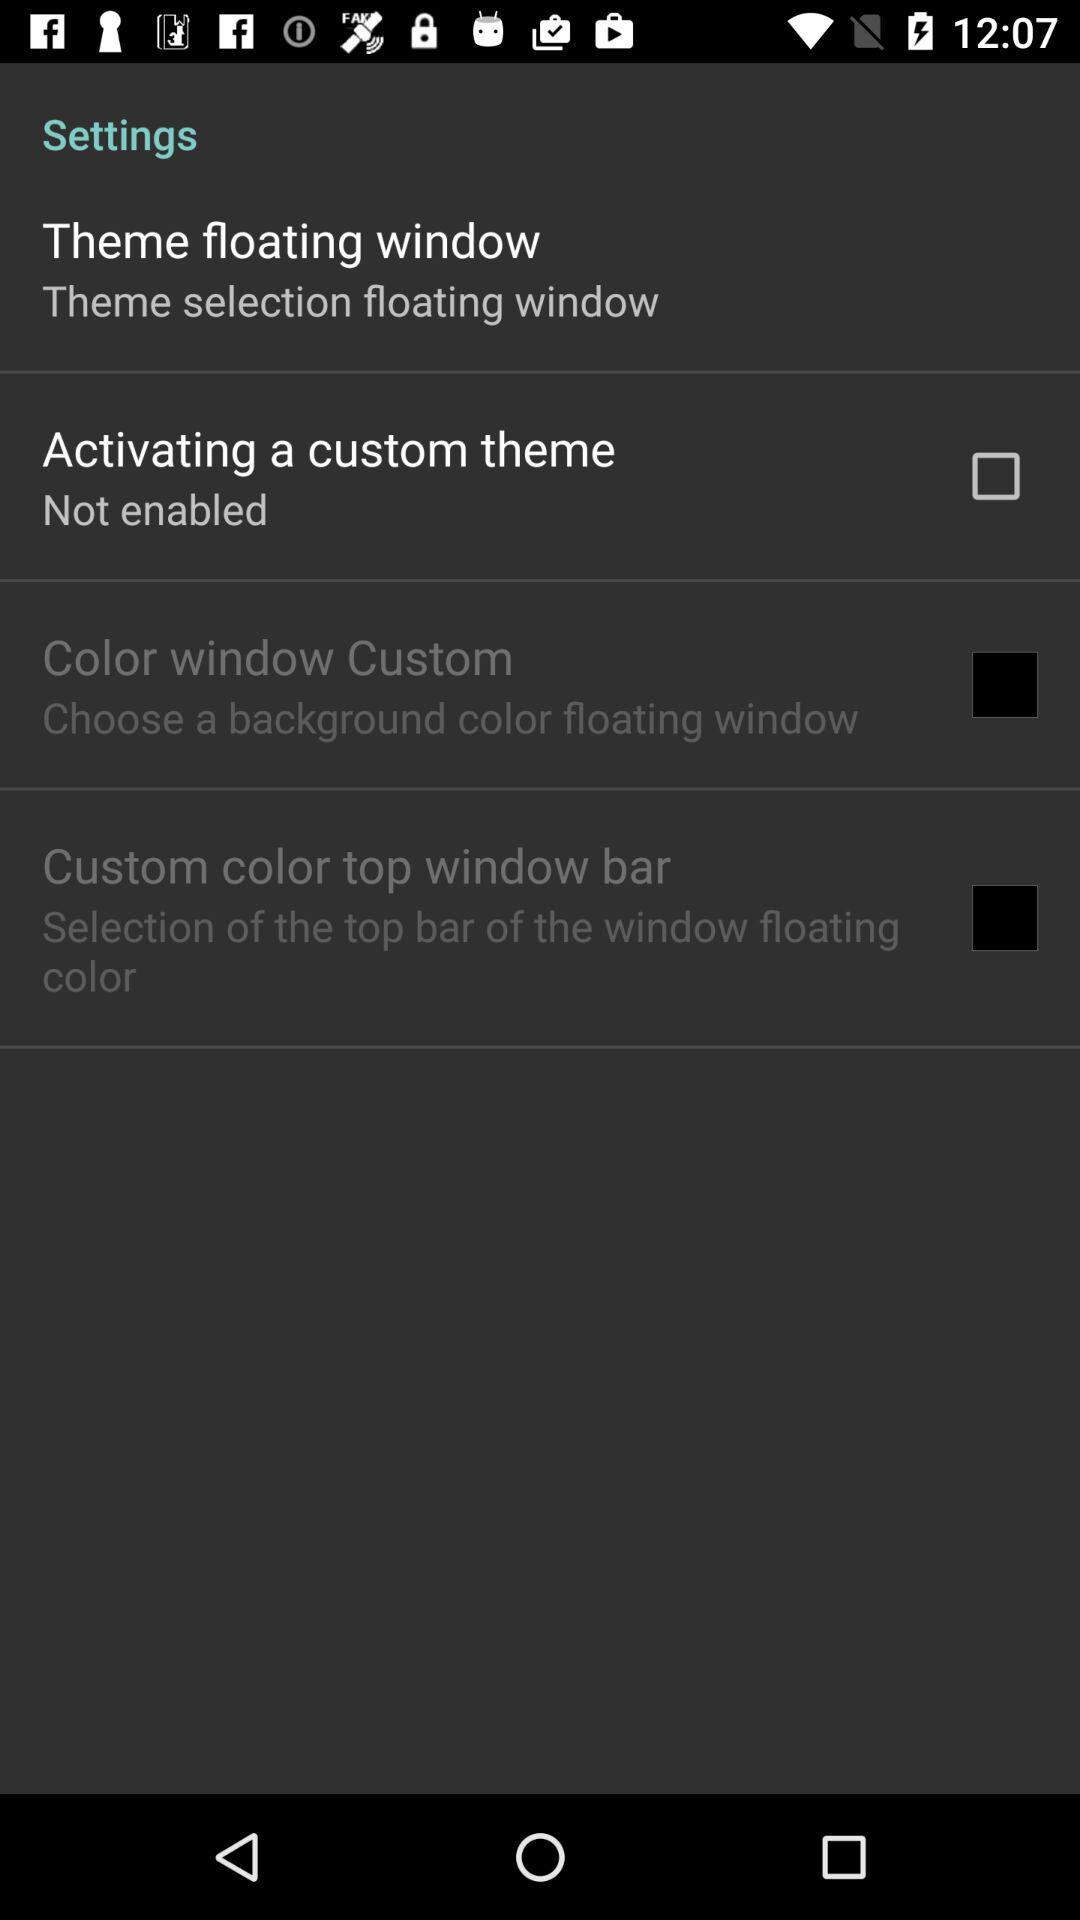What is the status of "Activating a custom theme"? The status is "off". 